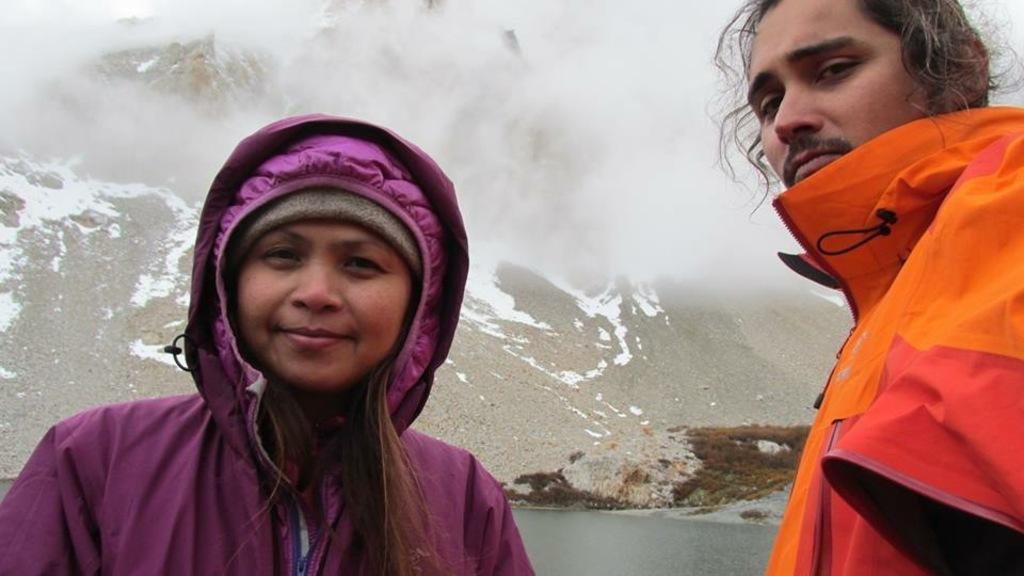Could you give a brief overview of what you see in this image? In this image I can see two people wearing purple and orange color coat. Back I can see mountains,water and fog. 